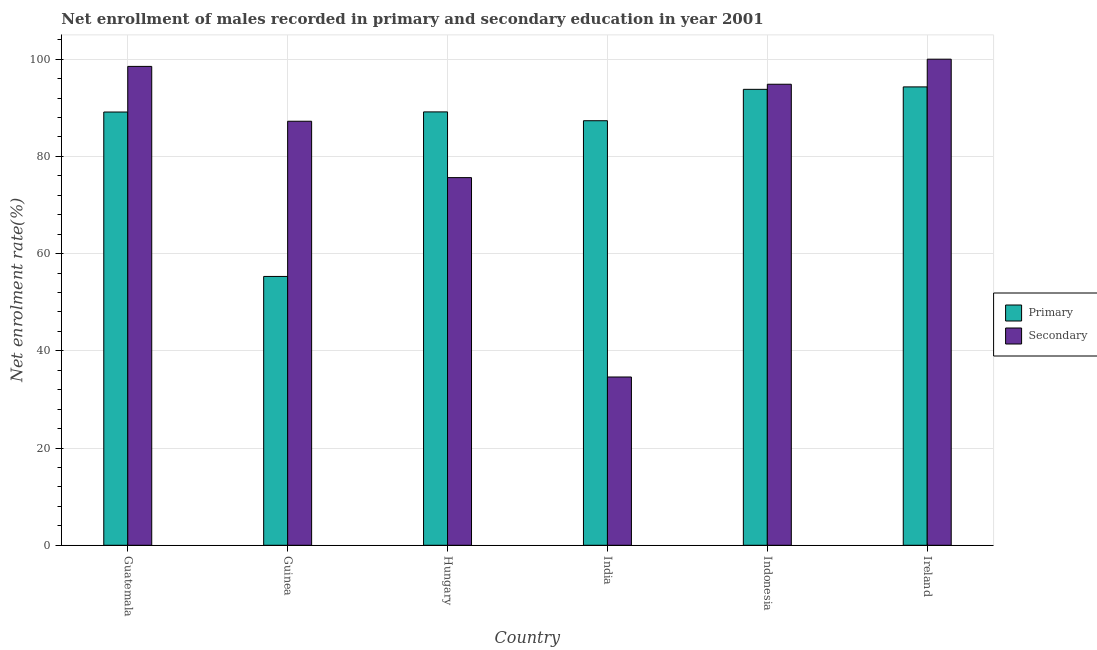How many groups of bars are there?
Your answer should be compact. 6. Are the number of bars on each tick of the X-axis equal?
Keep it short and to the point. Yes. How many bars are there on the 3rd tick from the left?
Keep it short and to the point. 2. What is the label of the 1st group of bars from the left?
Keep it short and to the point. Guatemala. In how many cases, is the number of bars for a given country not equal to the number of legend labels?
Your response must be concise. 0. What is the enrollment rate in secondary education in Indonesia?
Offer a terse response. 94.85. Across all countries, what is the maximum enrollment rate in primary education?
Your answer should be very brief. 94.3. Across all countries, what is the minimum enrollment rate in secondary education?
Your response must be concise. 34.62. In which country was the enrollment rate in secondary education maximum?
Make the answer very short. Ireland. In which country was the enrollment rate in secondary education minimum?
Offer a terse response. India. What is the total enrollment rate in primary education in the graph?
Make the answer very short. 509.02. What is the difference between the enrollment rate in secondary education in Guatemala and that in Guinea?
Your answer should be compact. 11.28. What is the difference between the enrollment rate in primary education in India and the enrollment rate in secondary education in Guinea?
Provide a short and direct response. 0.11. What is the average enrollment rate in secondary education per country?
Provide a short and direct response. 81.81. What is the difference between the enrollment rate in primary education and enrollment rate in secondary education in India?
Your answer should be compact. 52.72. What is the ratio of the enrollment rate in primary education in Indonesia to that in Ireland?
Offer a terse response. 0.99. What is the difference between the highest and the second highest enrollment rate in secondary education?
Give a very brief answer. 1.48. What is the difference between the highest and the lowest enrollment rate in primary education?
Ensure brevity in your answer.  38.99. Is the sum of the enrollment rate in secondary education in Hungary and Indonesia greater than the maximum enrollment rate in primary education across all countries?
Offer a terse response. Yes. What does the 2nd bar from the left in Ireland represents?
Ensure brevity in your answer.  Secondary. What does the 1st bar from the right in Guatemala represents?
Offer a terse response. Secondary. How many bars are there?
Your answer should be compact. 12. What is the difference between two consecutive major ticks on the Y-axis?
Provide a short and direct response. 20. Does the graph contain any zero values?
Your answer should be compact. No. Does the graph contain grids?
Keep it short and to the point. Yes. Where does the legend appear in the graph?
Your response must be concise. Center right. How are the legend labels stacked?
Offer a very short reply. Vertical. What is the title of the graph?
Ensure brevity in your answer.  Net enrollment of males recorded in primary and secondary education in year 2001. What is the label or title of the X-axis?
Your answer should be very brief. Country. What is the label or title of the Y-axis?
Provide a short and direct response. Net enrolment rate(%). What is the Net enrolment rate(%) in Primary in Guatemala?
Your answer should be very brief. 89.13. What is the Net enrolment rate(%) in Secondary in Guatemala?
Provide a short and direct response. 98.52. What is the Net enrolment rate(%) of Primary in Guinea?
Keep it short and to the point. 55.31. What is the Net enrolment rate(%) in Secondary in Guinea?
Your answer should be compact. 87.23. What is the Net enrolment rate(%) in Primary in Hungary?
Offer a terse response. 89.15. What is the Net enrolment rate(%) of Secondary in Hungary?
Provide a short and direct response. 75.63. What is the Net enrolment rate(%) in Primary in India?
Make the answer very short. 87.34. What is the Net enrolment rate(%) in Secondary in India?
Provide a succinct answer. 34.62. What is the Net enrolment rate(%) in Primary in Indonesia?
Make the answer very short. 93.8. What is the Net enrolment rate(%) of Secondary in Indonesia?
Make the answer very short. 94.85. What is the Net enrolment rate(%) in Primary in Ireland?
Give a very brief answer. 94.3. Across all countries, what is the maximum Net enrolment rate(%) of Primary?
Your response must be concise. 94.3. Across all countries, what is the minimum Net enrolment rate(%) in Primary?
Your response must be concise. 55.31. Across all countries, what is the minimum Net enrolment rate(%) in Secondary?
Give a very brief answer. 34.62. What is the total Net enrolment rate(%) of Primary in the graph?
Ensure brevity in your answer.  509.02. What is the total Net enrolment rate(%) in Secondary in the graph?
Provide a short and direct response. 490.85. What is the difference between the Net enrolment rate(%) of Primary in Guatemala and that in Guinea?
Give a very brief answer. 33.82. What is the difference between the Net enrolment rate(%) of Secondary in Guatemala and that in Guinea?
Your answer should be very brief. 11.28. What is the difference between the Net enrolment rate(%) of Primary in Guatemala and that in Hungary?
Provide a short and direct response. -0.03. What is the difference between the Net enrolment rate(%) in Secondary in Guatemala and that in Hungary?
Make the answer very short. 22.88. What is the difference between the Net enrolment rate(%) in Primary in Guatemala and that in India?
Ensure brevity in your answer.  1.79. What is the difference between the Net enrolment rate(%) of Secondary in Guatemala and that in India?
Provide a succinct answer. 63.9. What is the difference between the Net enrolment rate(%) of Primary in Guatemala and that in Indonesia?
Keep it short and to the point. -4.67. What is the difference between the Net enrolment rate(%) in Secondary in Guatemala and that in Indonesia?
Your answer should be very brief. 3.67. What is the difference between the Net enrolment rate(%) in Primary in Guatemala and that in Ireland?
Provide a short and direct response. -5.17. What is the difference between the Net enrolment rate(%) in Secondary in Guatemala and that in Ireland?
Make the answer very short. -1.48. What is the difference between the Net enrolment rate(%) in Primary in Guinea and that in Hungary?
Keep it short and to the point. -33.85. What is the difference between the Net enrolment rate(%) in Secondary in Guinea and that in Hungary?
Offer a terse response. 11.6. What is the difference between the Net enrolment rate(%) of Primary in Guinea and that in India?
Give a very brief answer. -32.03. What is the difference between the Net enrolment rate(%) in Secondary in Guinea and that in India?
Your answer should be compact. 52.61. What is the difference between the Net enrolment rate(%) in Primary in Guinea and that in Indonesia?
Provide a short and direct response. -38.49. What is the difference between the Net enrolment rate(%) in Secondary in Guinea and that in Indonesia?
Keep it short and to the point. -7.61. What is the difference between the Net enrolment rate(%) in Primary in Guinea and that in Ireland?
Make the answer very short. -38.99. What is the difference between the Net enrolment rate(%) in Secondary in Guinea and that in Ireland?
Offer a terse response. -12.77. What is the difference between the Net enrolment rate(%) of Primary in Hungary and that in India?
Give a very brief answer. 1.81. What is the difference between the Net enrolment rate(%) in Secondary in Hungary and that in India?
Provide a succinct answer. 41.02. What is the difference between the Net enrolment rate(%) in Primary in Hungary and that in Indonesia?
Keep it short and to the point. -4.64. What is the difference between the Net enrolment rate(%) of Secondary in Hungary and that in Indonesia?
Provide a succinct answer. -19.21. What is the difference between the Net enrolment rate(%) in Primary in Hungary and that in Ireland?
Make the answer very short. -5.14. What is the difference between the Net enrolment rate(%) in Secondary in Hungary and that in Ireland?
Your response must be concise. -24.37. What is the difference between the Net enrolment rate(%) of Primary in India and that in Indonesia?
Keep it short and to the point. -6.46. What is the difference between the Net enrolment rate(%) in Secondary in India and that in Indonesia?
Offer a terse response. -60.23. What is the difference between the Net enrolment rate(%) in Primary in India and that in Ireland?
Ensure brevity in your answer.  -6.96. What is the difference between the Net enrolment rate(%) in Secondary in India and that in Ireland?
Your answer should be very brief. -65.38. What is the difference between the Net enrolment rate(%) of Primary in Indonesia and that in Ireland?
Provide a short and direct response. -0.5. What is the difference between the Net enrolment rate(%) in Secondary in Indonesia and that in Ireland?
Give a very brief answer. -5.15. What is the difference between the Net enrolment rate(%) in Primary in Guatemala and the Net enrolment rate(%) in Secondary in Guinea?
Offer a very short reply. 1.9. What is the difference between the Net enrolment rate(%) of Primary in Guatemala and the Net enrolment rate(%) of Secondary in Hungary?
Keep it short and to the point. 13.49. What is the difference between the Net enrolment rate(%) in Primary in Guatemala and the Net enrolment rate(%) in Secondary in India?
Give a very brief answer. 54.51. What is the difference between the Net enrolment rate(%) of Primary in Guatemala and the Net enrolment rate(%) of Secondary in Indonesia?
Make the answer very short. -5.72. What is the difference between the Net enrolment rate(%) in Primary in Guatemala and the Net enrolment rate(%) in Secondary in Ireland?
Keep it short and to the point. -10.87. What is the difference between the Net enrolment rate(%) in Primary in Guinea and the Net enrolment rate(%) in Secondary in Hungary?
Your answer should be very brief. -20.33. What is the difference between the Net enrolment rate(%) in Primary in Guinea and the Net enrolment rate(%) in Secondary in India?
Your response must be concise. 20.69. What is the difference between the Net enrolment rate(%) in Primary in Guinea and the Net enrolment rate(%) in Secondary in Indonesia?
Provide a short and direct response. -39.54. What is the difference between the Net enrolment rate(%) of Primary in Guinea and the Net enrolment rate(%) of Secondary in Ireland?
Your response must be concise. -44.69. What is the difference between the Net enrolment rate(%) of Primary in Hungary and the Net enrolment rate(%) of Secondary in India?
Offer a terse response. 54.54. What is the difference between the Net enrolment rate(%) of Primary in Hungary and the Net enrolment rate(%) of Secondary in Indonesia?
Provide a succinct answer. -5.69. What is the difference between the Net enrolment rate(%) in Primary in Hungary and the Net enrolment rate(%) in Secondary in Ireland?
Keep it short and to the point. -10.85. What is the difference between the Net enrolment rate(%) of Primary in India and the Net enrolment rate(%) of Secondary in Indonesia?
Give a very brief answer. -7.51. What is the difference between the Net enrolment rate(%) in Primary in India and the Net enrolment rate(%) in Secondary in Ireland?
Offer a very short reply. -12.66. What is the difference between the Net enrolment rate(%) in Primary in Indonesia and the Net enrolment rate(%) in Secondary in Ireland?
Ensure brevity in your answer.  -6.2. What is the average Net enrolment rate(%) of Primary per country?
Make the answer very short. 84.84. What is the average Net enrolment rate(%) of Secondary per country?
Your answer should be compact. 81.81. What is the difference between the Net enrolment rate(%) in Primary and Net enrolment rate(%) in Secondary in Guatemala?
Offer a very short reply. -9.39. What is the difference between the Net enrolment rate(%) of Primary and Net enrolment rate(%) of Secondary in Guinea?
Provide a short and direct response. -31.93. What is the difference between the Net enrolment rate(%) of Primary and Net enrolment rate(%) of Secondary in Hungary?
Your response must be concise. 13.52. What is the difference between the Net enrolment rate(%) in Primary and Net enrolment rate(%) in Secondary in India?
Offer a terse response. 52.72. What is the difference between the Net enrolment rate(%) of Primary and Net enrolment rate(%) of Secondary in Indonesia?
Keep it short and to the point. -1.05. What is the difference between the Net enrolment rate(%) of Primary and Net enrolment rate(%) of Secondary in Ireland?
Give a very brief answer. -5.7. What is the ratio of the Net enrolment rate(%) of Primary in Guatemala to that in Guinea?
Ensure brevity in your answer.  1.61. What is the ratio of the Net enrolment rate(%) of Secondary in Guatemala to that in Guinea?
Your response must be concise. 1.13. What is the ratio of the Net enrolment rate(%) in Secondary in Guatemala to that in Hungary?
Provide a succinct answer. 1.3. What is the ratio of the Net enrolment rate(%) in Primary in Guatemala to that in India?
Give a very brief answer. 1.02. What is the ratio of the Net enrolment rate(%) in Secondary in Guatemala to that in India?
Ensure brevity in your answer.  2.85. What is the ratio of the Net enrolment rate(%) of Primary in Guatemala to that in Indonesia?
Your answer should be compact. 0.95. What is the ratio of the Net enrolment rate(%) of Secondary in Guatemala to that in Indonesia?
Provide a succinct answer. 1.04. What is the ratio of the Net enrolment rate(%) in Primary in Guatemala to that in Ireland?
Your answer should be very brief. 0.95. What is the ratio of the Net enrolment rate(%) of Secondary in Guatemala to that in Ireland?
Provide a short and direct response. 0.99. What is the ratio of the Net enrolment rate(%) in Primary in Guinea to that in Hungary?
Give a very brief answer. 0.62. What is the ratio of the Net enrolment rate(%) of Secondary in Guinea to that in Hungary?
Your answer should be compact. 1.15. What is the ratio of the Net enrolment rate(%) in Primary in Guinea to that in India?
Offer a terse response. 0.63. What is the ratio of the Net enrolment rate(%) of Secondary in Guinea to that in India?
Provide a short and direct response. 2.52. What is the ratio of the Net enrolment rate(%) in Primary in Guinea to that in Indonesia?
Make the answer very short. 0.59. What is the ratio of the Net enrolment rate(%) in Secondary in Guinea to that in Indonesia?
Make the answer very short. 0.92. What is the ratio of the Net enrolment rate(%) of Primary in Guinea to that in Ireland?
Your answer should be very brief. 0.59. What is the ratio of the Net enrolment rate(%) of Secondary in Guinea to that in Ireland?
Provide a short and direct response. 0.87. What is the ratio of the Net enrolment rate(%) of Primary in Hungary to that in India?
Provide a short and direct response. 1.02. What is the ratio of the Net enrolment rate(%) in Secondary in Hungary to that in India?
Provide a succinct answer. 2.18. What is the ratio of the Net enrolment rate(%) of Primary in Hungary to that in Indonesia?
Give a very brief answer. 0.95. What is the ratio of the Net enrolment rate(%) of Secondary in Hungary to that in Indonesia?
Give a very brief answer. 0.8. What is the ratio of the Net enrolment rate(%) in Primary in Hungary to that in Ireland?
Make the answer very short. 0.95. What is the ratio of the Net enrolment rate(%) of Secondary in Hungary to that in Ireland?
Your response must be concise. 0.76. What is the ratio of the Net enrolment rate(%) of Primary in India to that in Indonesia?
Keep it short and to the point. 0.93. What is the ratio of the Net enrolment rate(%) of Secondary in India to that in Indonesia?
Give a very brief answer. 0.36. What is the ratio of the Net enrolment rate(%) of Primary in India to that in Ireland?
Keep it short and to the point. 0.93. What is the ratio of the Net enrolment rate(%) of Secondary in India to that in Ireland?
Ensure brevity in your answer.  0.35. What is the ratio of the Net enrolment rate(%) of Secondary in Indonesia to that in Ireland?
Your answer should be very brief. 0.95. What is the difference between the highest and the second highest Net enrolment rate(%) in Primary?
Provide a short and direct response. 0.5. What is the difference between the highest and the second highest Net enrolment rate(%) of Secondary?
Ensure brevity in your answer.  1.48. What is the difference between the highest and the lowest Net enrolment rate(%) in Primary?
Provide a short and direct response. 38.99. What is the difference between the highest and the lowest Net enrolment rate(%) in Secondary?
Provide a succinct answer. 65.38. 